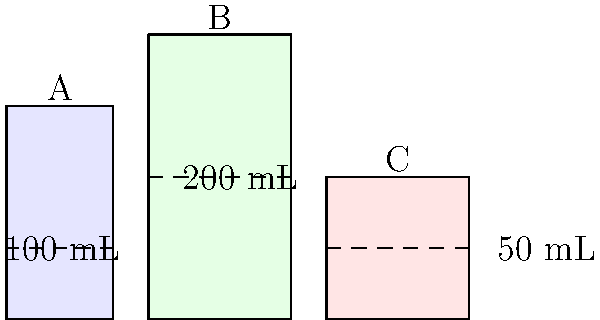A patient requires a 150 mL dose of medication. Based on the visual representation of containers A, B, and C, which combination of containers would you use to measure the correct dose most accurately? To solve this problem, let's analyze the information provided in the image:

1. Container A: 100 mL capacity (filled to the dashed line)
2. Container B: 200 mL capacity (filled to the dashed line)
3. Container C: 50 mL capacity (filled to the dashed line)

The required dose is 150 mL. To measure this accurately, we need to consider the following steps:

1. We need a combination that adds up to exactly 150 mL.
2. Using the largest possible containers reduces the number of measurements and potential errors.

Considering these factors:

- Container B (200 mL) is too large for our needs.
- Container A (100 mL) can be used as a base measurement.
- Container C (50 mL) can be used to add the remaining amount needed.

Therefore, the most accurate combination would be:
Container A (100 mL) + Container C (50 mL) = 150 mL

This combination uses the largest possible containers while still providing an exact measurement of the required dose.
Answer: Container A + Container C 